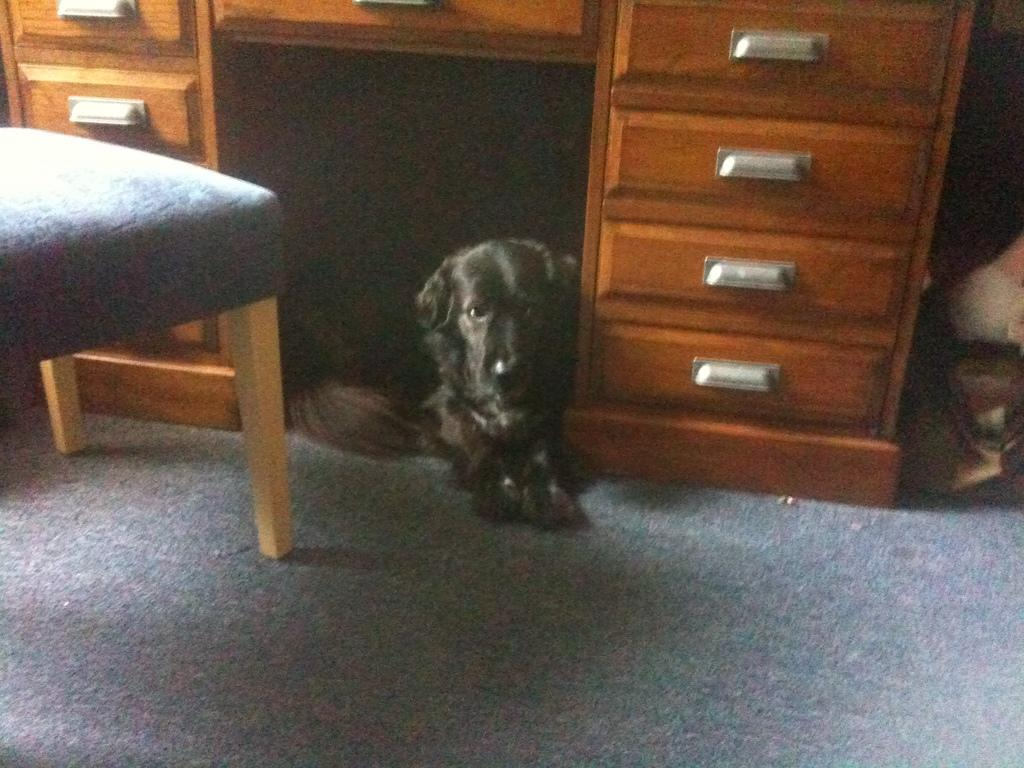What type of furniture is present in the image? There is a chair in the image. What animal can be seen on the floor? There is a black color dog on the floor. What type of string is the dog playing with in the image? There is no string present in the image, and the dog is not shown playing with anything. 